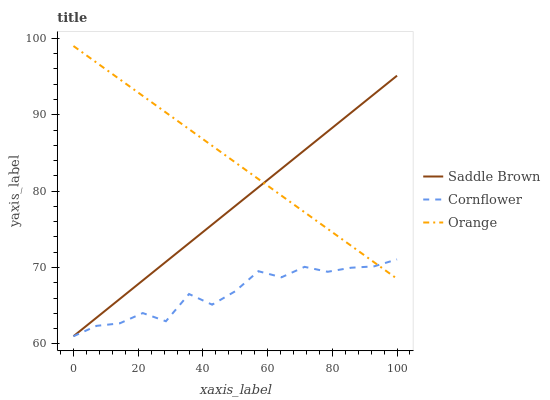Does Saddle Brown have the minimum area under the curve?
Answer yes or no. No. Does Saddle Brown have the maximum area under the curve?
Answer yes or no. No. Is Cornflower the smoothest?
Answer yes or no. No. Is Saddle Brown the roughest?
Answer yes or no. No. Does Saddle Brown have the highest value?
Answer yes or no. No. 